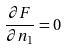Convert formula to latex. <formula><loc_0><loc_0><loc_500><loc_500>\frac { \partial F } { \partial n _ { 1 } } = 0</formula> 